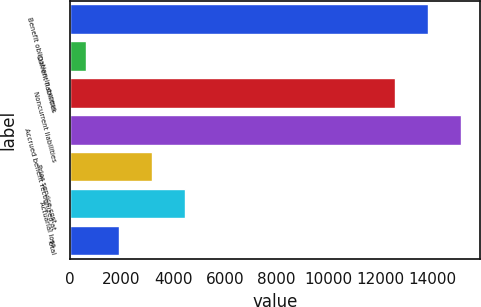Convert chart to OTSL. <chart><loc_0><loc_0><loc_500><loc_500><bar_chart><fcel>Benefit obligation in excess<fcel>Current liabilities<fcel>Noncurrent liabilities<fcel>Accrued benefit recognized at<fcel>Prior service cost<fcel>Actuarial loss<fcel>Total<nl><fcel>13829.9<fcel>633<fcel>12559<fcel>15100.8<fcel>3174.8<fcel>4445.7<fcel>1903.9<nl></chart> 